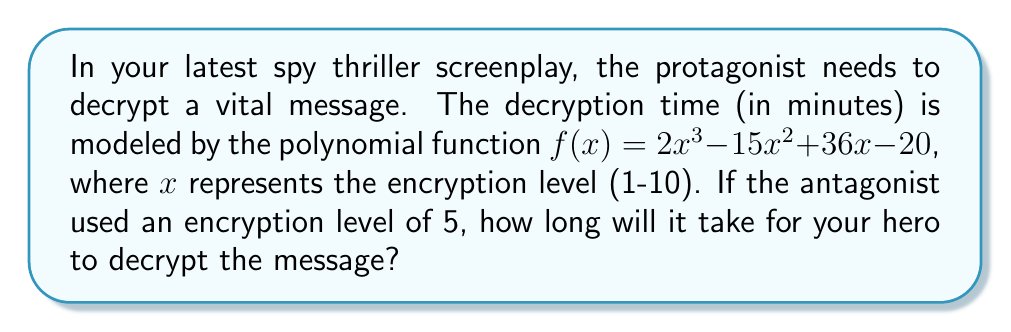Could you help me with this problem? To solve this problem, we need to evaluate the polynomial function $f(x)$ at $x = 5$. Let's break it down step by step:

1) The given function is $f(x) = 2x^3 - 15x^2 + 36x - 20$

2) We need to calculate $f(5)$:
   $f(5) = 2(5^3) - 15(5^2) + 36(5) - 20$

3) Let's evaluate each term:
   - $2(5^3) = 2(125) = 250$
   - $15(5^2) = 15(25) = 375$
   - $36(5) = 180$
   - The last term is already simplified: $-20$

4) Now, let's combine these terms:
   $f(5) = 250 - 375 + 180 - 20$

5) Simplifying:
   $f(5) = 35$

Therefore, it will take 35 minutes for the hero to decrypt the message.
Answer: 35 minutes 